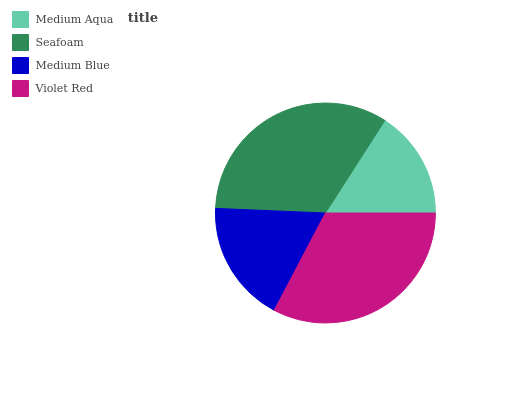Is Medium Aqua the minimum?
Answer yes or no. Yes. Is Seafoam the maximum?
Answer yes or no. Yes. Is Medium Blue the minimum?
Answer yes or no. No. Is Medium Blue the maximum?
Answer yes or no. No. Is Seafoam greater than Medium Blue?
Answer yes or no. Yes. Is Medium Blue less than Seafoam?
Answer yes or no. Yes. Is Medium Blue greater than Seafoam?
Answer yes or no. No. Is Seafoam less than Medium Blue?
Answer yes or no. No. Is Violet Red the high median?
Answer yes or no. Yes. Is Medium Blue the low median?
Answer yes or no. Yes. Is Seafoam the high median?
Answer yes or no. No. Is Medium Aqua the low median?
Answer yes or no. No. 